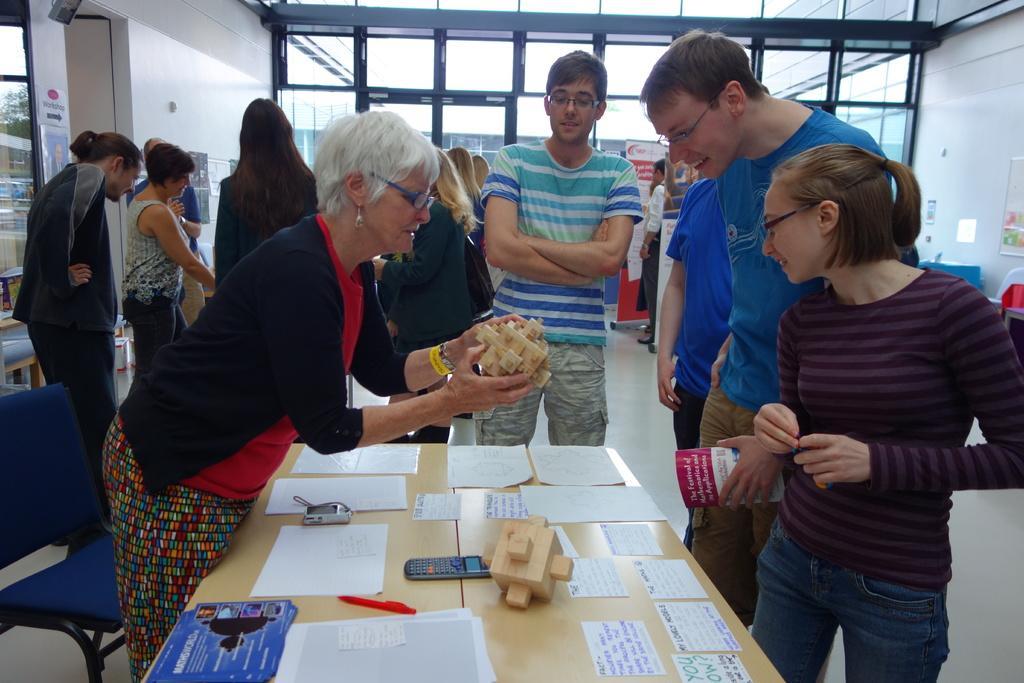How would you summarize this image in a sentence or two? There are many people standing. In front of picture there is a table. On the table there are many papers, labels, calculator, pen,posters. To the left there is a women with black jacket she is standing and holding wood in her hand. And in the background there are some glass door. to the left corner there is a door. 